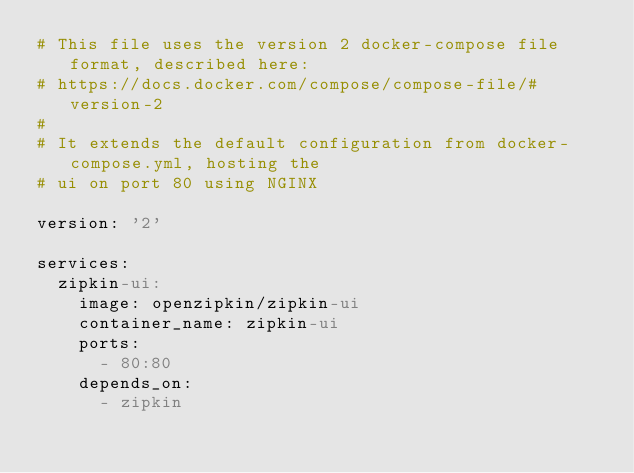<code> <loc_0><loc_0><loc_500><loc_500><_YAML_># This file uses the version 2 docker-compose file format, described here:
# https://docs.docker.com/compose/compose-file/#version-2
#
# It extends the default configuration from docker-compose.yml, hosting the
# ui on port 80 using NGINX

version: '2'

services:
  zipkin-ui:
    image: openzipkin/zipkin-ui
    container_name: zipkin-ui
    ports:
      - 80:80
    depends_on:
      - zipkin
</code> 